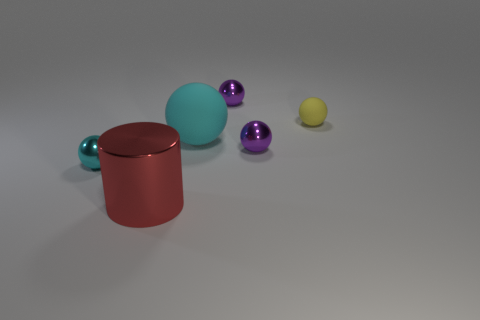There is a object that is the same color as the big ball; what shape is it?
Provide a short and direct response. Sphere. There is a purple metallic ball that is in front of the large ball; what is its size?
Your answer should be compact. Small. Are there more large cyan matte objects than tiny blocks?
Offer a very short reply. Yes. How many shiny objects are both in front of the small cyan ball and right of the large cyan sphere?
Make the answer very short. 0. What is the shape of the cyan thing that is behind the tiny thing to the left of the cyan sphere behind the cyan metallic thing?
Make the answer very short. Sphere. Are there any other things that are the same shape as the big metal thing?
Your response must be concise. No. How many cylinders are either small yellow matte things or rubber things?
Provide a short and direct response. 0. There is a large thing that is behind the small cyan metallic sphere; is it the same color as the tiny matte sphere?
Provide a short and direct response. No. What material is the small purple ball that is in front of the rubber thing behind the cyan object that is to the right of the big red object made of?
Provide a short and direct response. Metal. Do the yellow thing and the red shiny cylinder have the same size?
Provide a short and direct response. No. 